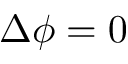<formula> <loc_0><loc_0><loc_500><loc_500>\Delta \phi = 0</formula> 